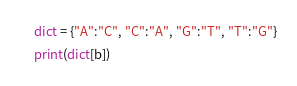<code> <loc_0><loc_0><loc_500><loc_500><_Python_>dict = {"A":"C", "C":"A", "G":"T", "T":"G"}
print(dict[b])
</code> 